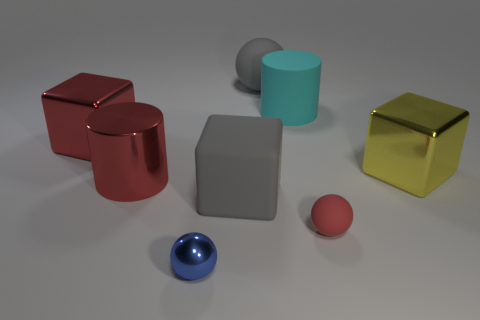What might be the purpose of arranging these objects in such a way? This arrangement of objects may be designed to create a visual composition for artistic or illustrative purposes, such as a study of color interaction, form, and material contrast. It can also serve instructional purposes, acting as a reference image for teaching aspects of three-dimensional rendering, such as lighting, shadow, and reflection dynamics in computer graphics. 